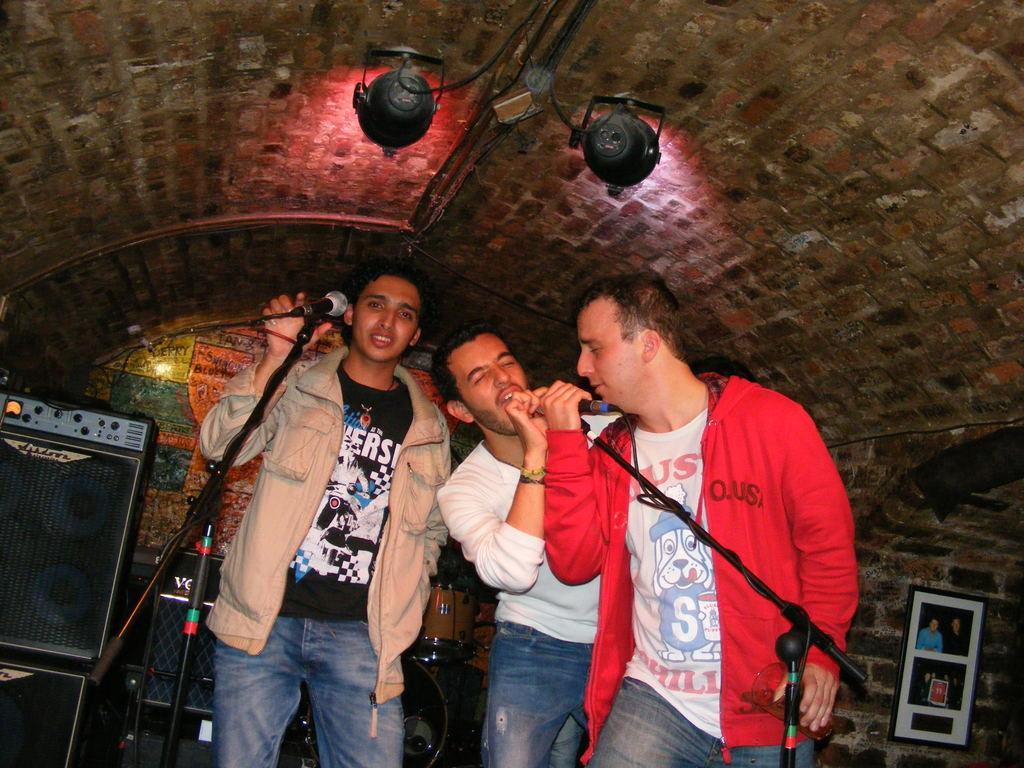Please provide a concise description of this image. In this image we can three persons are standing and holding mics. In the background we can see speaker box, drums, photo frames and lights 